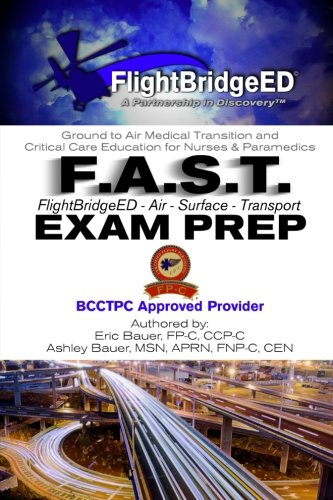What is the genre of this book? This book falls under the category of medical educational resources, specifically tailored for those preparing for certification exams in air and surface medical transport. 